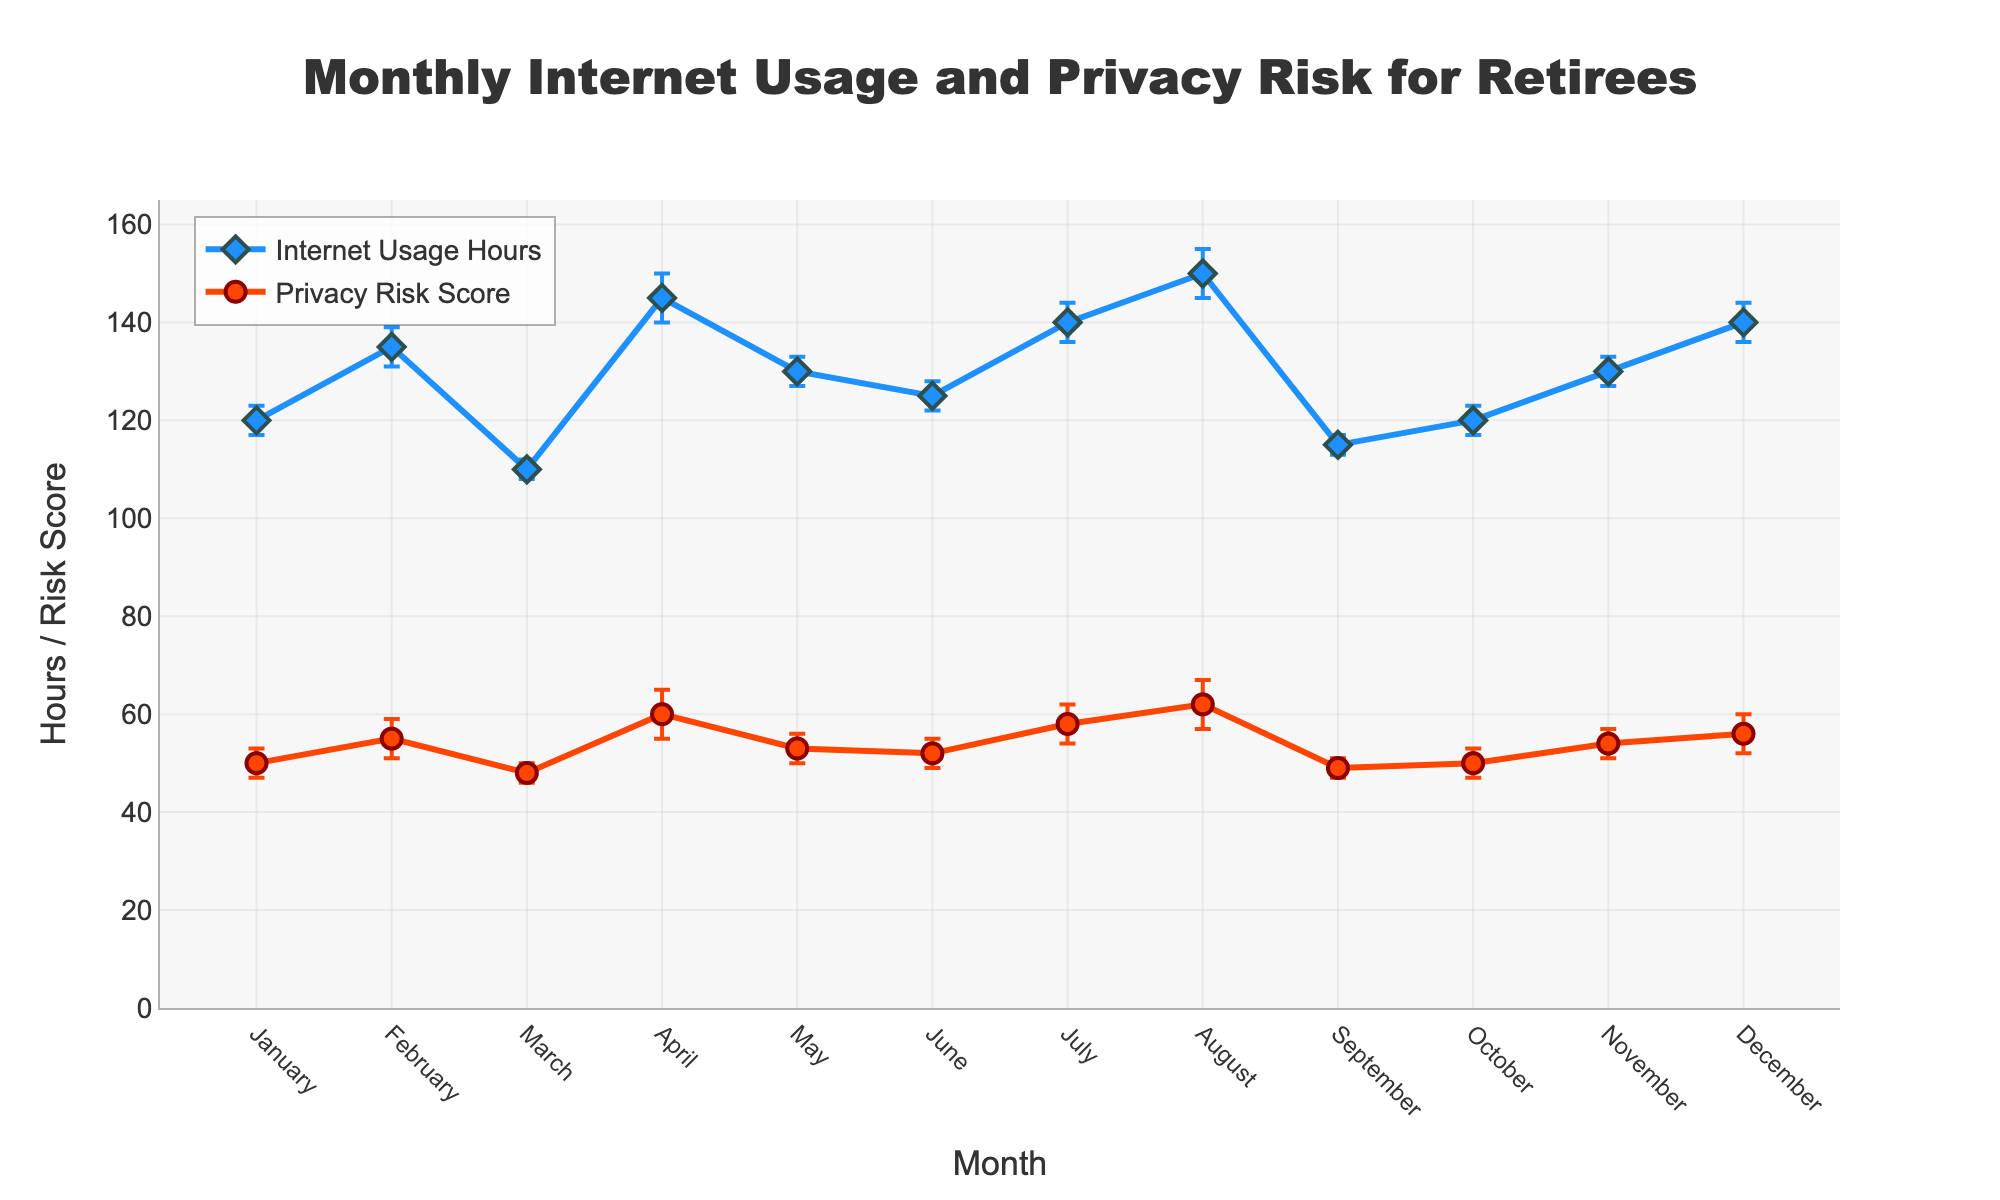How many different months are presented in the figure? The x-axis represents the months and there are labeled points from January to December, which totals 12 months.
Answer: 12 What is the highest value of Internet Usage Hours recorded in the figure? The highest value in the presented Internet Usage Hours is seen in August, with a value of 150 hours.
Answer: 150 In which month is the Privacy Risk Score the highest? The figure shows the highest Privacy Risk Score in August, with a score of 62.
Answer: August Which month has the lowest Internet Usage Hours, and what is the value? The figure indicates that March and September both have the lowest Internet Usage Hours, each with a value of 110 and 115 respectively.
Answer: March (110), September (115) Is there a month where Internet Usage Hours and Privacy Risk Score are equal or very close? In February, Internet Usage Hours is 135 and Privacy Risk Score is 55. Although the values are not equal, they are relatively close in their respective scales.
Answer: No What is the average value of Internet Usage Hours over the months? Summing all Internet Usage Hours (120 + 135 + 110 + 145 + 130 + 125 + 140 + 150 + 115 + 120 + 130 + 140 = 1560) and dividing by the number of months (12) gives the average: 1560/12 = 130.
Answer: 130 What is the difference in Privacy Risk Score between the month with the highest score and the month with the lowest score? The highest Privacy Risk Score is in August (62) and the lowest is in March (48). The difference is 62 - 48 = 14.
Answer: 14 How are the error bars visually represented in the figure? The error bars appear as vertical lines above and below the plotted data points, indicating the standard error for both Internet Usage Hours and Privacy Risk Score.
Answer: Vertical lines Which month shows the largest error bar in Internet Usage Hours, and what is the size of this error? April and August both show the largest error bars for Internet Usage Hours, each with a standard error of 5 hours.
Answer: April, August (5) Is there a clear trend of increasing or decreasing Internet Usage Hours over the months? The plot shows fluctuations in Internet Usage Hours without a clear trend, as the values rise and fall across different months.
Answer: No 